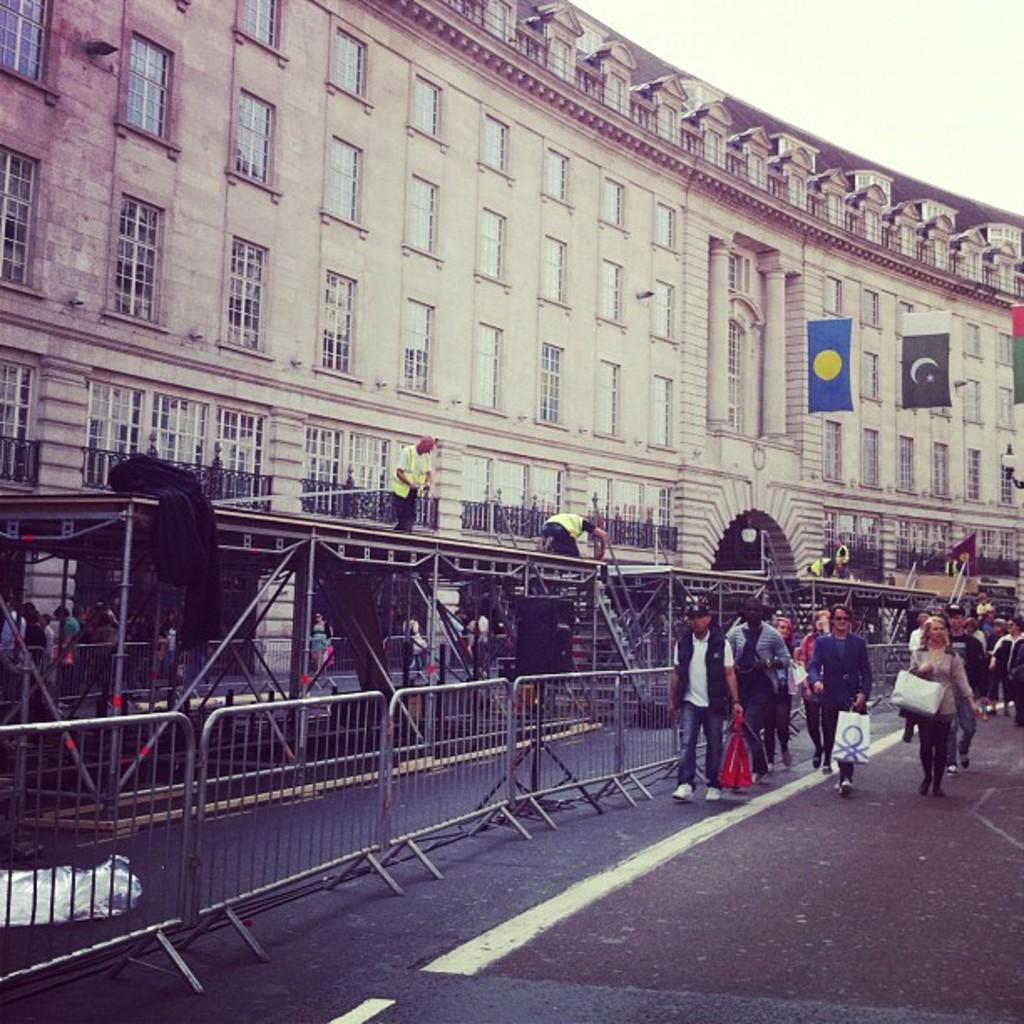Could you give a brief overview of what you see in this image? In this picture we can see there are some people walking and some people are standing on the path and on the left side of the people there are barriers and some other objects. Behind the people there are flags, building and a sky. 